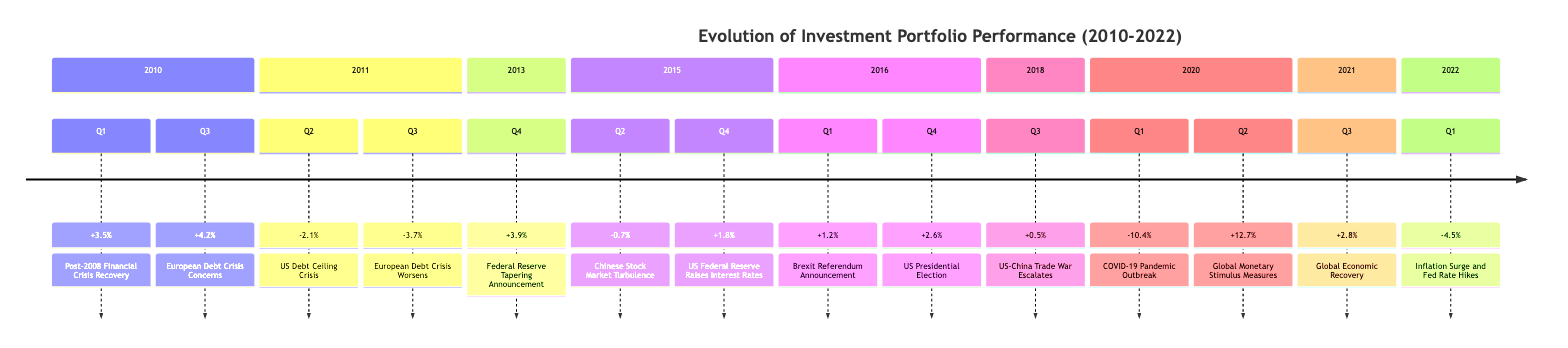What was the return in Q1 of 2010? The diagram shows that in Q1 of 2010, the return was +3.5%.
Answer: +3.5% Which economic event is associated with Q2 of 2011? The diagram indicates that Q2 of 2011 is associated with the "US Debt Ceiling Crisis."
Answer: US Debt Ceiling Crisis How many economic events are recorded for the year 2015? According to the diagram, there are two events for the year 2015: one in Q2 and one in Q4.
Answer: 2 What was the performance return in Q1 of 2020? In Q1 of 2020, the diagram specifies a performance return of -10.4%.
Answer: -10.4% Which quarter had the highest return in 2020? By examining the diagram, the highest return in 2020 was in Q2, which was +12.7%.
Answer: Q2 What is the overall trend in returns from Q1 2020 to Q1 2022? The diagram shows that the returns moved from -10.4% in Q1 2020 to -4.5% in Q1 2022, indicating a trend of improvement yet remaining negative.
Answer: Improvement In which year did the "Federal Reserve Tapering Announcement" occur? The diagram indicates that the "Federal Reserve Tapering Announcement" occurred in Q4 of 2013.
Answer: 2013 What was the event associated with the lowest return in 2011? The lowest return in 2011 is linked to the event "European Debt Crisis Worsens" in Q3, which had a return of -3.7%.
Answer: European Debt Crisis Worsens What was the return in Q3 of 2021? According to the diagram, the return in Q3 of 2021 was +2.8%.
Answer: +2.8% 